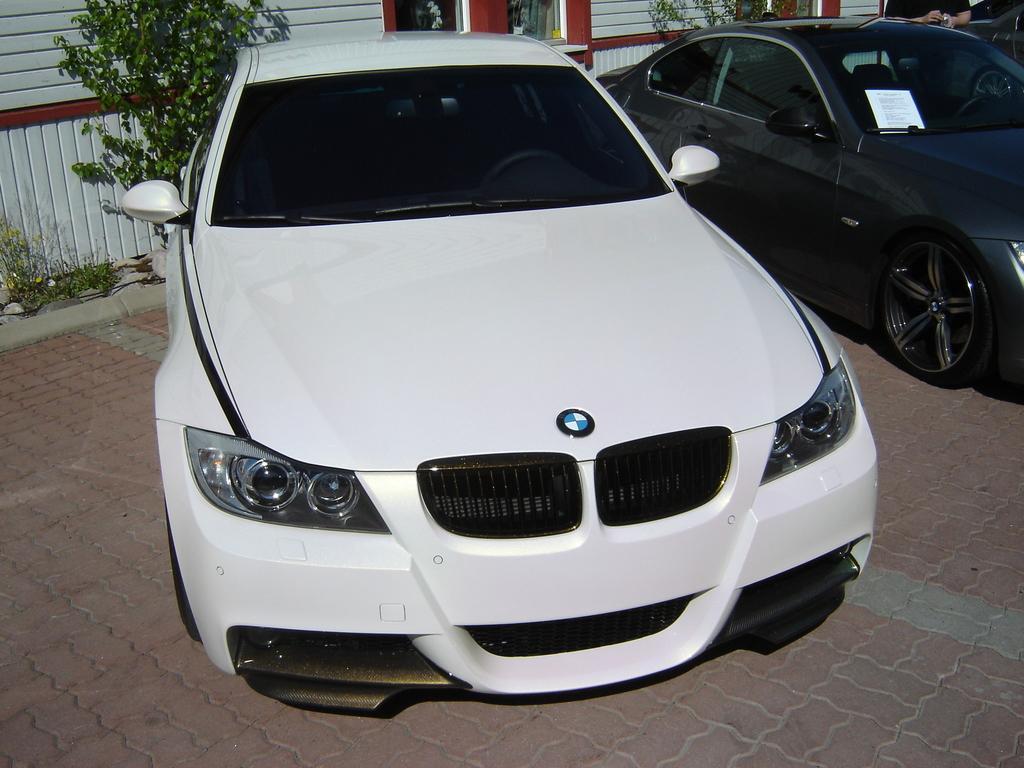How would you summarize this image in a sentence or two? In this image, I can see two cars on the road. In the background, there are trees, plants and the windows to the wall. At the top right side of the image, there is another car and a person standing. 